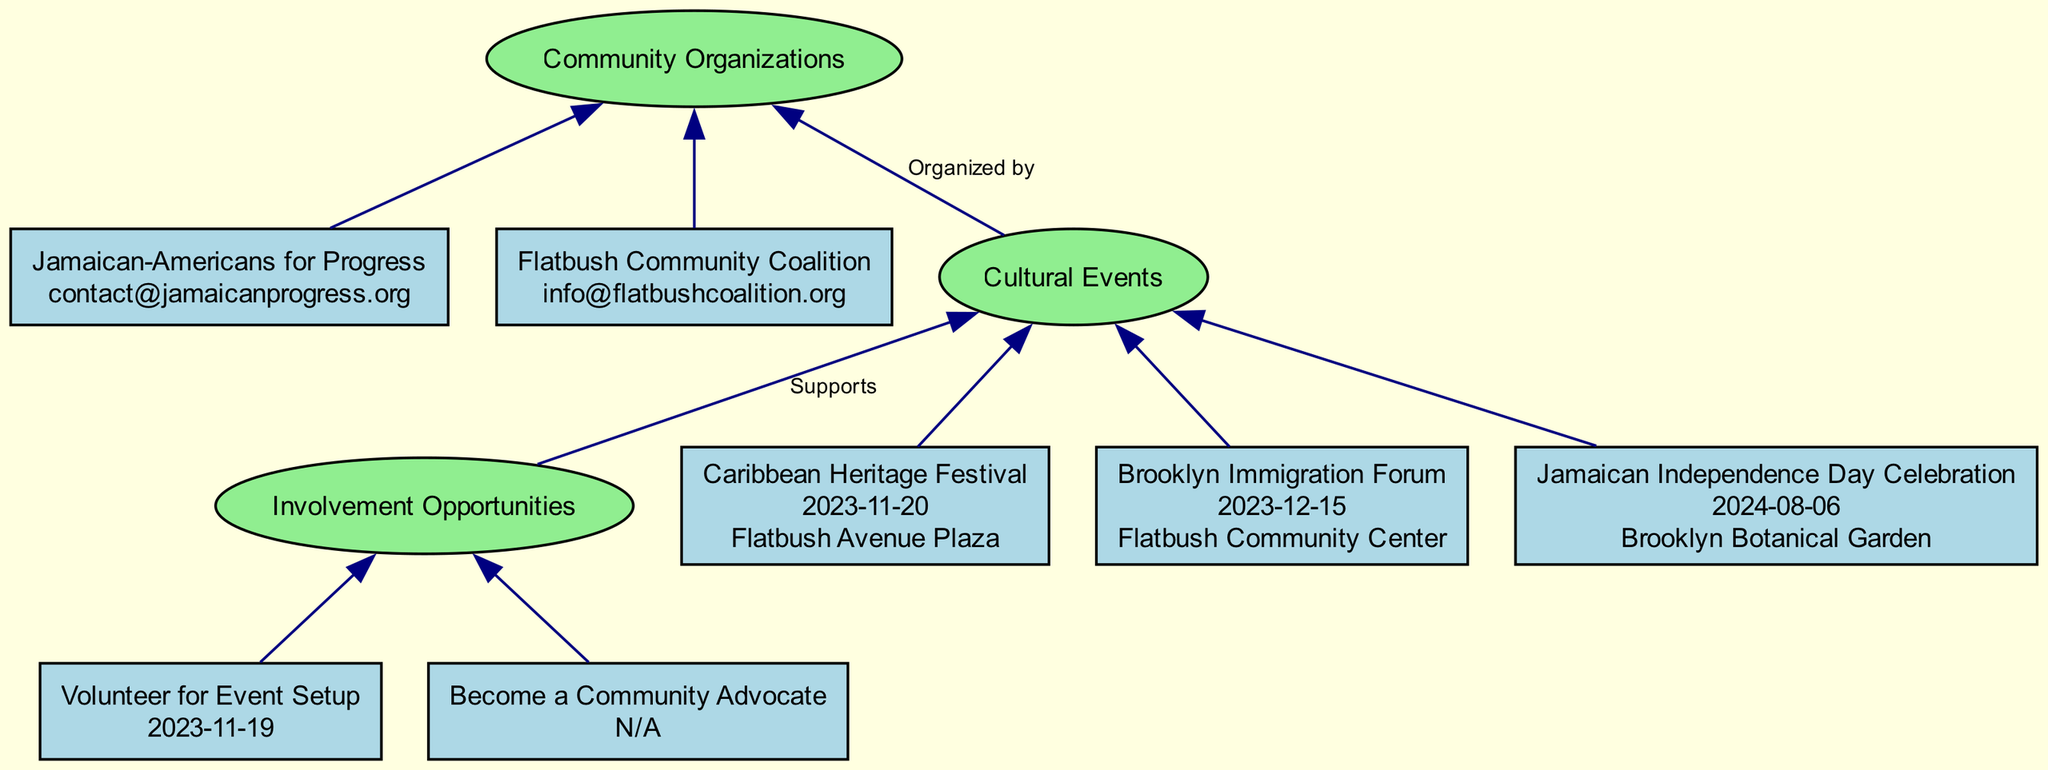What is the name of the first event listed? The diagram presents the events in the "Cultural Events" section. The first event listed is identified as "Caribbean Heritage Festival."
Answer: Caribbean Heritage Festival How many organizations are mentioned in the diagram? The "Community Organizations" section displays all the organizations listed in the diagram. There are two organizations mentioned in total.
Answer: 2 What date is the Brooklyn Immigration Forum scheduled for? The "Brooklyn Immigration Forum" event node contains the date information, which is explicitly listed as "2023-12-15."
Answer: 2023-12-15 What is the main focus of the involvement opportunity labeled "Become a Community Advocate"? The "Become a Community Advocate" opportunity provides a summary in the diagram indicating its focus on participation in discussions and advocacy efforts related to immigration reform.
Answer: Immigration reform Which organization organizes local cultural events? Referring to the organization nodes, "Flatbush Community Coalition" is explicitly noted for organizing local cultural events and community service opportunities.
Answer: Flatbush Community Coalition How does the "Involvement Opportunities" section relate to the "Cultural Events"? The edge labeled "Supports" indicates that the involvement opportunities are meant to support the cultural events, establishing a direct relationship between these sections.
Answer: Supports What type of events does the "Jamaican Independence Day Celebration" feature? By examining the details within the "Jamaican Independence Day Celebration" event, it mentions it features parades, food tasting, and family activities, identifying the types of events.
Answer: Parades, food tasting, family activities What service does "Jamaican-Americans for Progress" provide? The services offered by "Jamaican-Americans for Progress" are summarized in the organization node, indicating advocacy for immigrant rights and community outreach programs.
Answer: Advocacy for immigrant rights How many volunteers are needed for the event setup of the Caribbean Heritage Festival? The diagram does not provide a specific number of volunteers needed for the "Caribbean Heritage Festival." However, it does indicate there is a volunteer opportunity for event setup through the node labeled "Volunteer for Event Setup." The lack of a specific number indicates a general call for volunteers.
Answer: N/A 